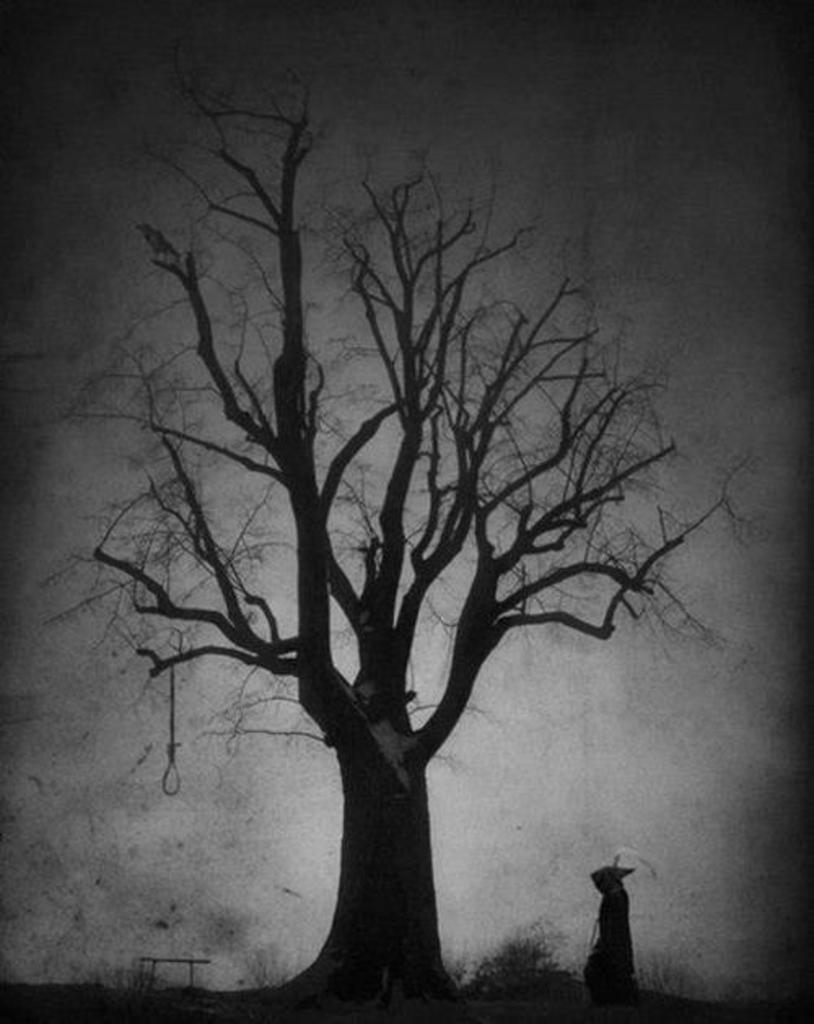Could you give a brief overview of what you see in this image? This is a black and white image in this image in the center there is one tree, on the tree there is one person and beside the tree there is another person and at the bottom there are some plants. 